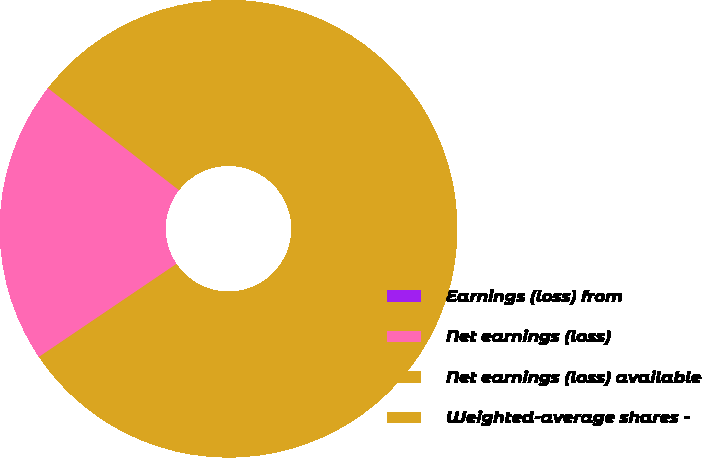Convert chart to OTSL. <chart><loc_0><loc_0><loc_500><loc_500><pie_chart><fcel>Earnings (loss) from<fcel>Net earnings (loss)<fcel>Net earnings (loss) available<fcel>Weighted-average shares -<nl><fcel>0.0%<fcel>20.0%<fcel>6.67%<fcel>73.33%<nl></chart> 